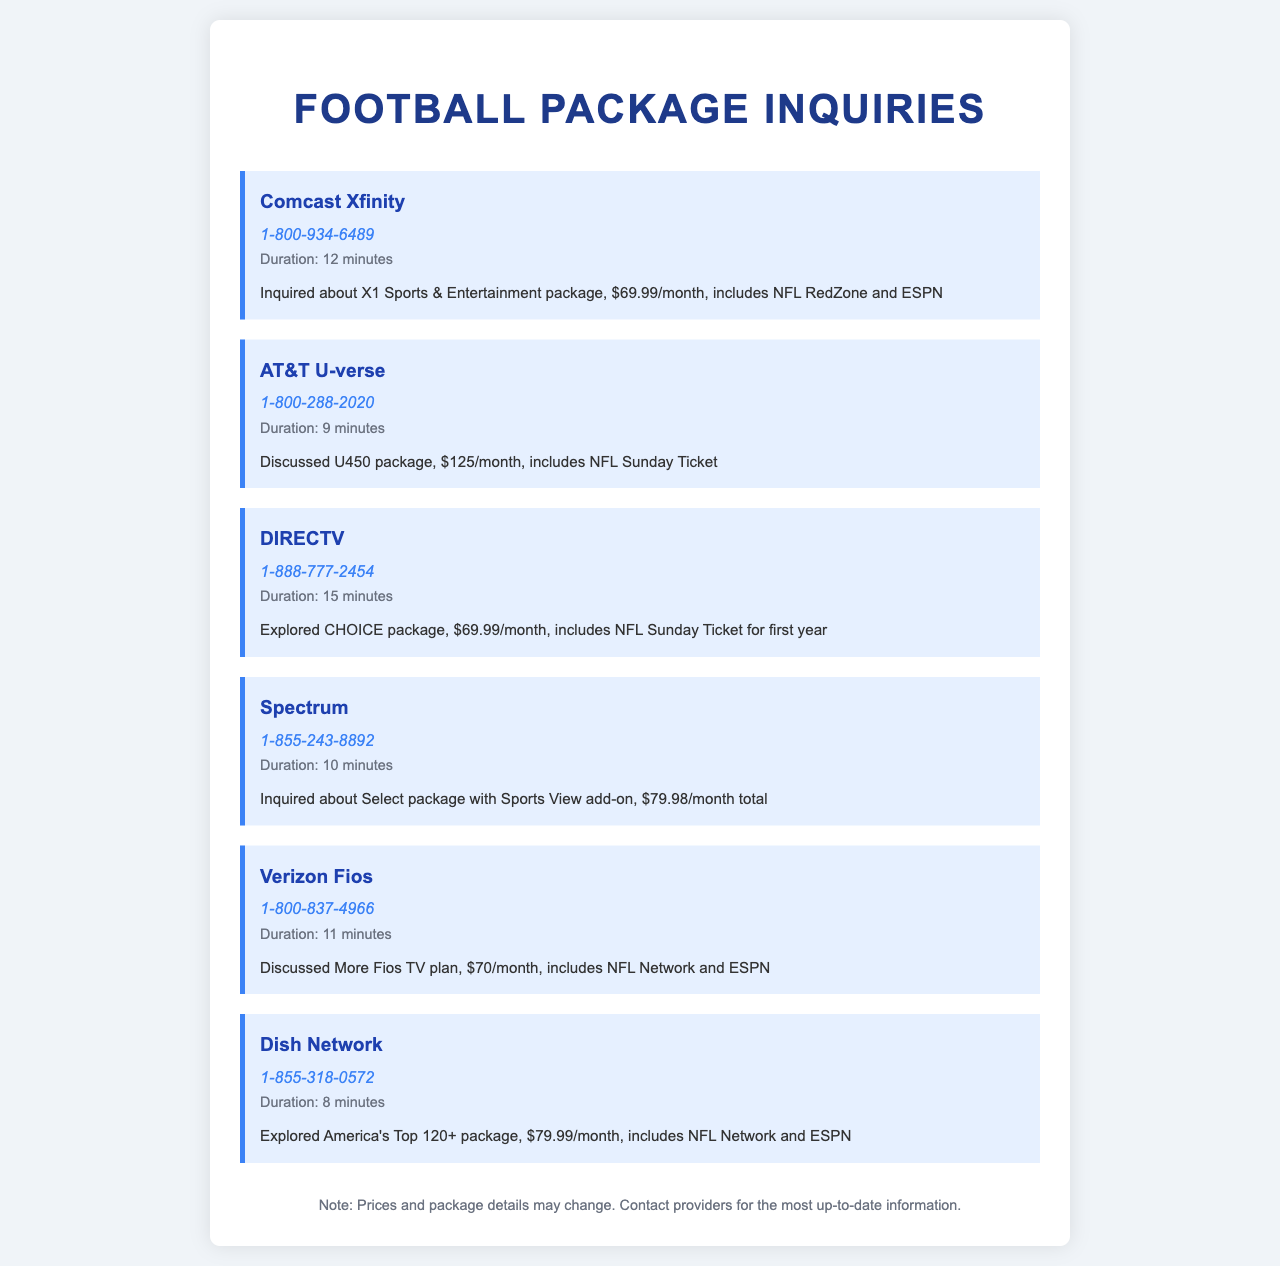What is the Comcast Xfinity package price? The document states that the Comcast Xfinity package is $69.99/month.
Answer: $69.99/month How many minutes was the call to DIRECTV? The document lists that the call to DIRECTV lasted for 15 minutes.
Answer: 15 minutes What package does Verizon Fios offer? According to the document, Verizon Fios offers the More Fios TV plan.
Answer: More Fios TV plan What is the total cost of Spectrum's Select package with add-on? The document indicates the total cost is $79.98/month for Spectrum's package.
Answer: $79.98/month Which provider offers the NFL Sunday Ticket for the first year? The document mentions that DIRECTV offers the NFL Sunday Ticket for the first year.
Answer: DIRECTV Which provider has the highest package price listed? The document notes that AT&T U-verse U450 package has the highest price at $125/month.
Answer: $125/month What football channel is included with Dish Network’s package? The document specifies that Dish Network's package includes the NFL Network.
Answer: NFL Network How long was the call to the AT&T U-verse provider? The call duration mentioned for AT&T U-verse is 9 minutes.
Answer: 9 minutes What is the name of the Comcast Xfinity sports package? The document states that the package name is X1 Sports & Entertainment.
Answer: X1 Sports & Entertainment 